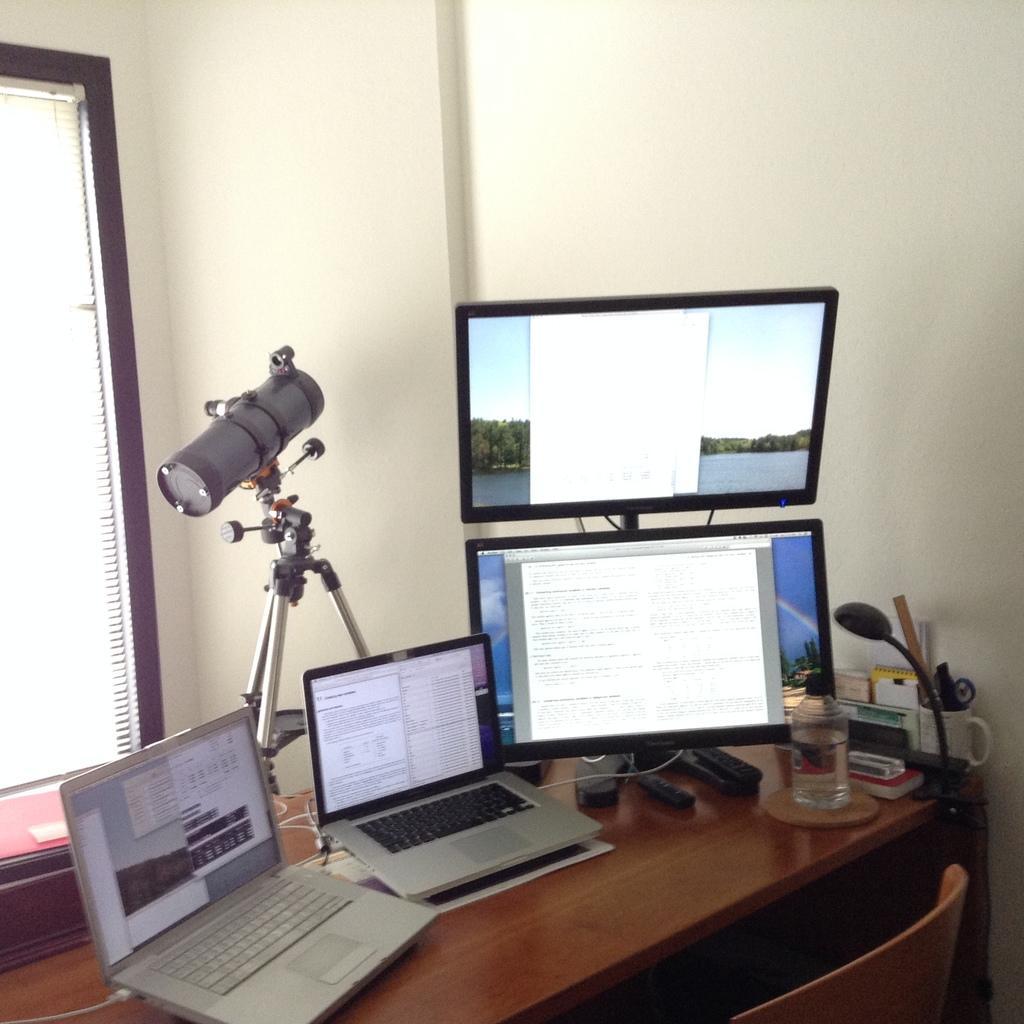Describe this image in one or two sentences. In this image on the table there is a laptop,monitor,bottle,cup and there is a chair. 